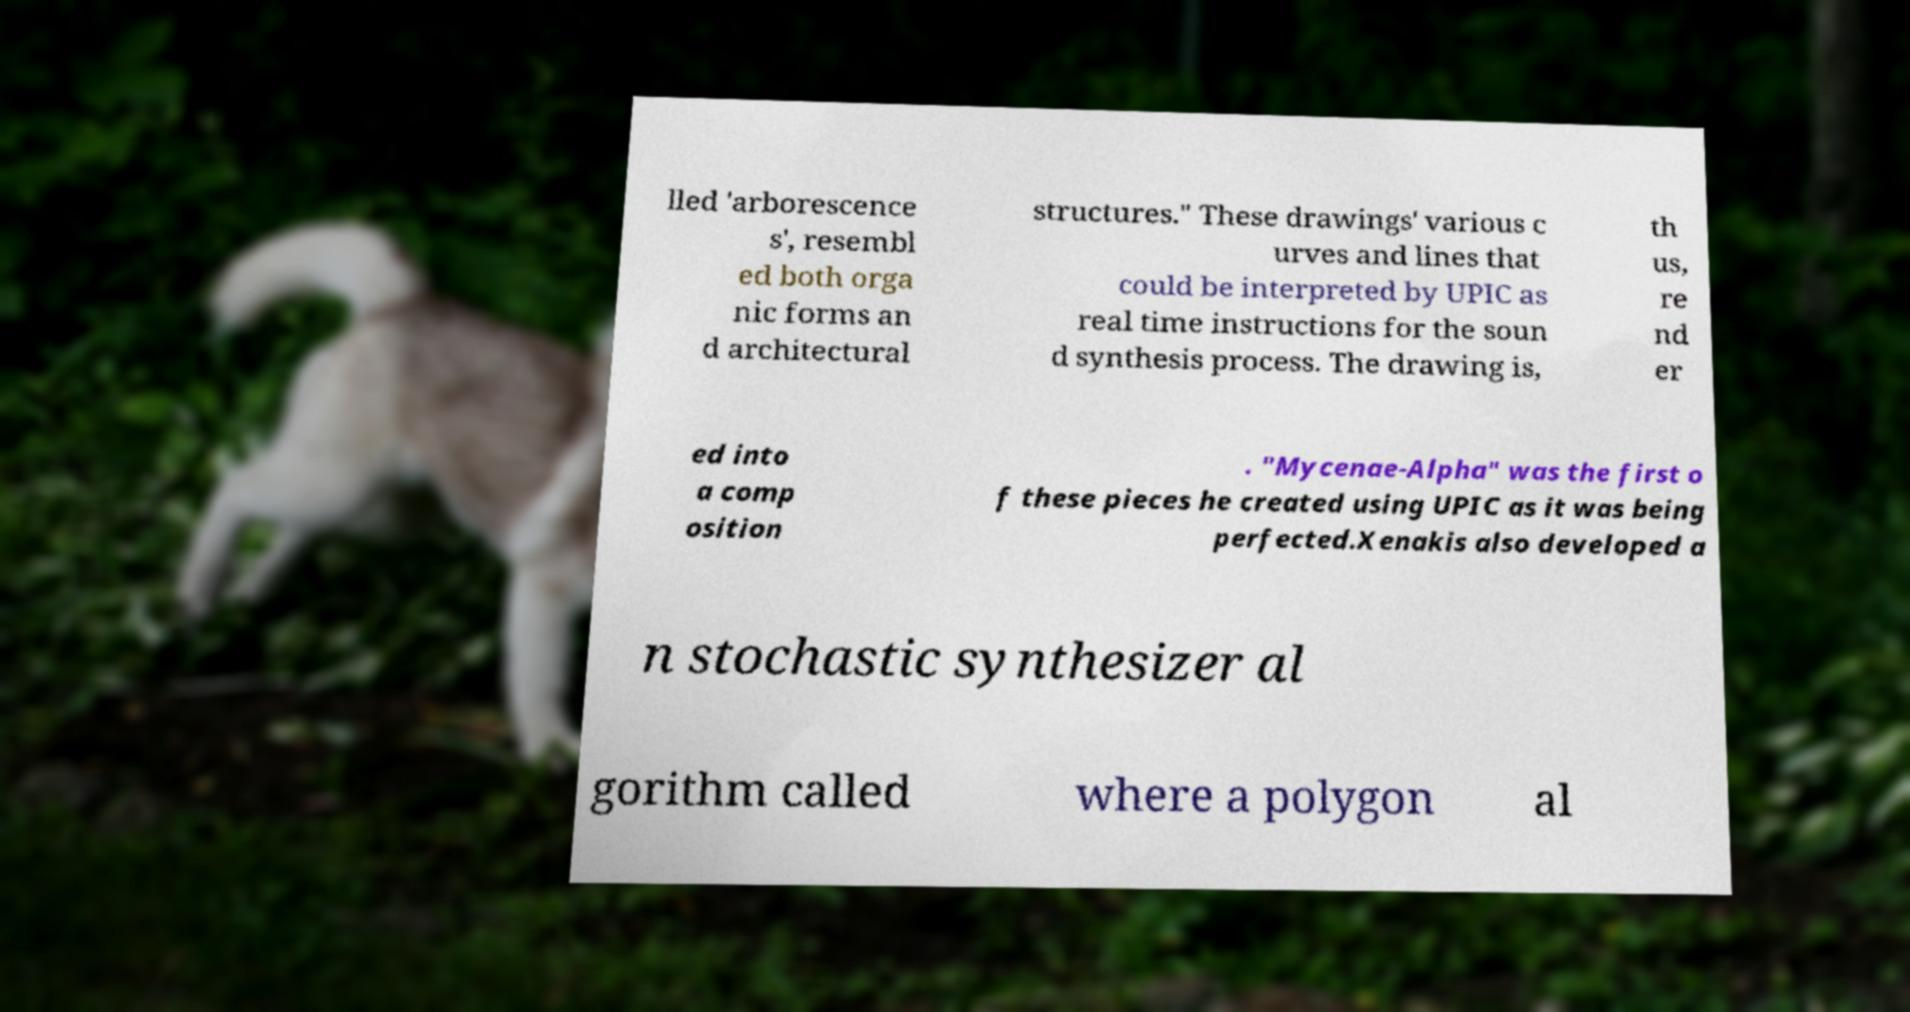For documentation purposes, I need the text within this image transcribed. Could you provide that? lled 'arborescence s', resembl ed both orga nic forms an d architectural structures." These drawings' various c urves and lines that could be interpreted by UPIC as real time instructions for the soun d synthesis process. The drawing is, th us, re nd er ed into a comp osition . "Mycenae-Alpha" was the first o f these pieces he created using UPIC as it was being perfected.Xenakis also developed a n stochastic synthesizer al gorithm called where a polygon al 